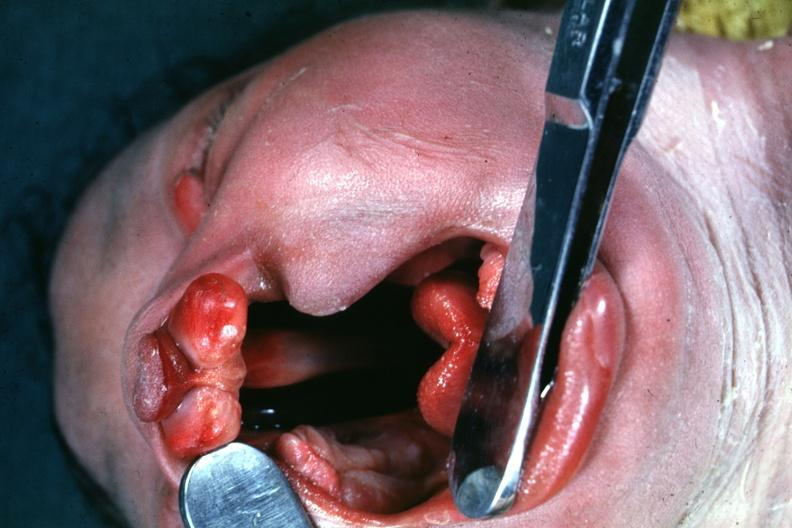s face present?
Answer the question using a single word or phrase. Yes 